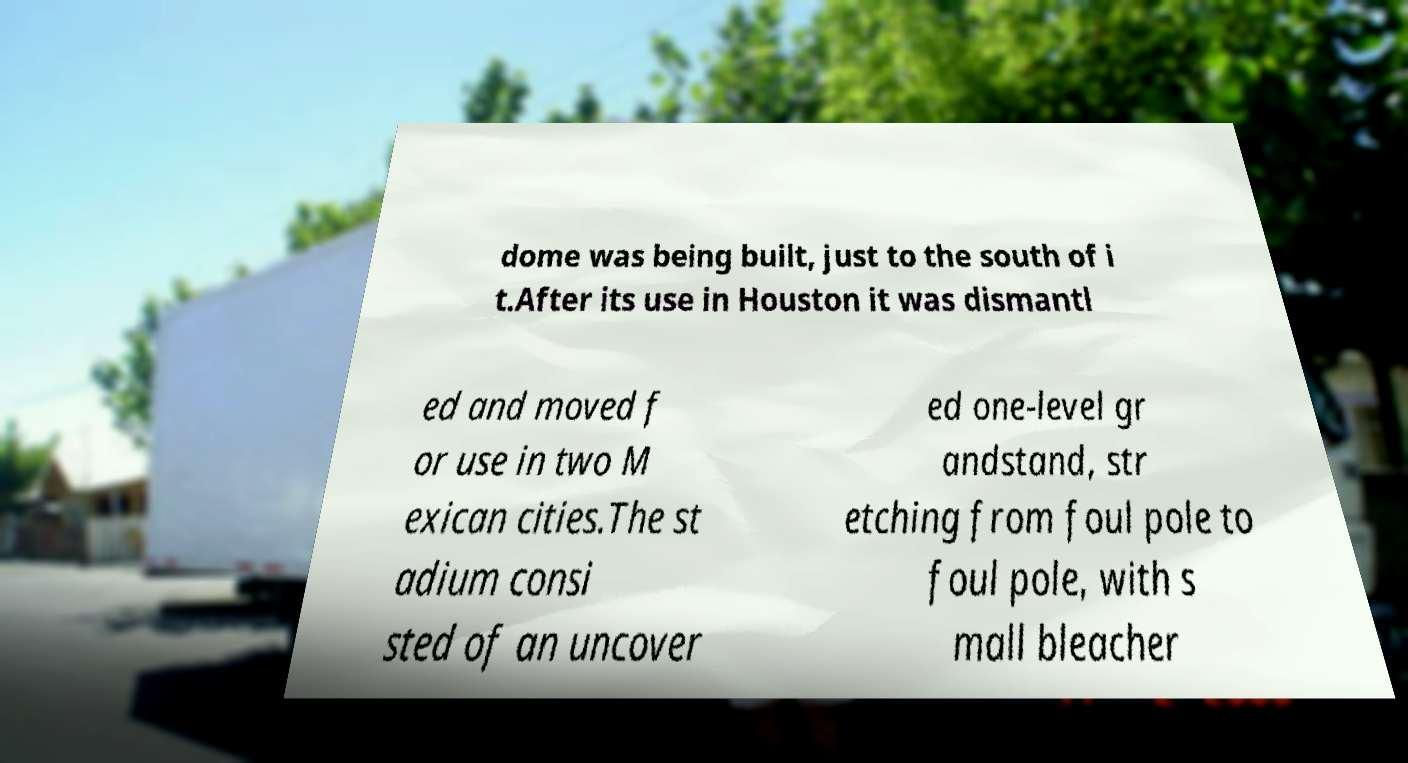What messages or text are displayed in this image? I need them in a readable, typed format. dome was being built, just to the south of i t.After its use in Houston it was dismantl ed and moved f or use in two M exican cities.The st adium consi sted of an uncover ed one-level gr andstand, str etching from foul pole to foul pole, with s mall bleacher 